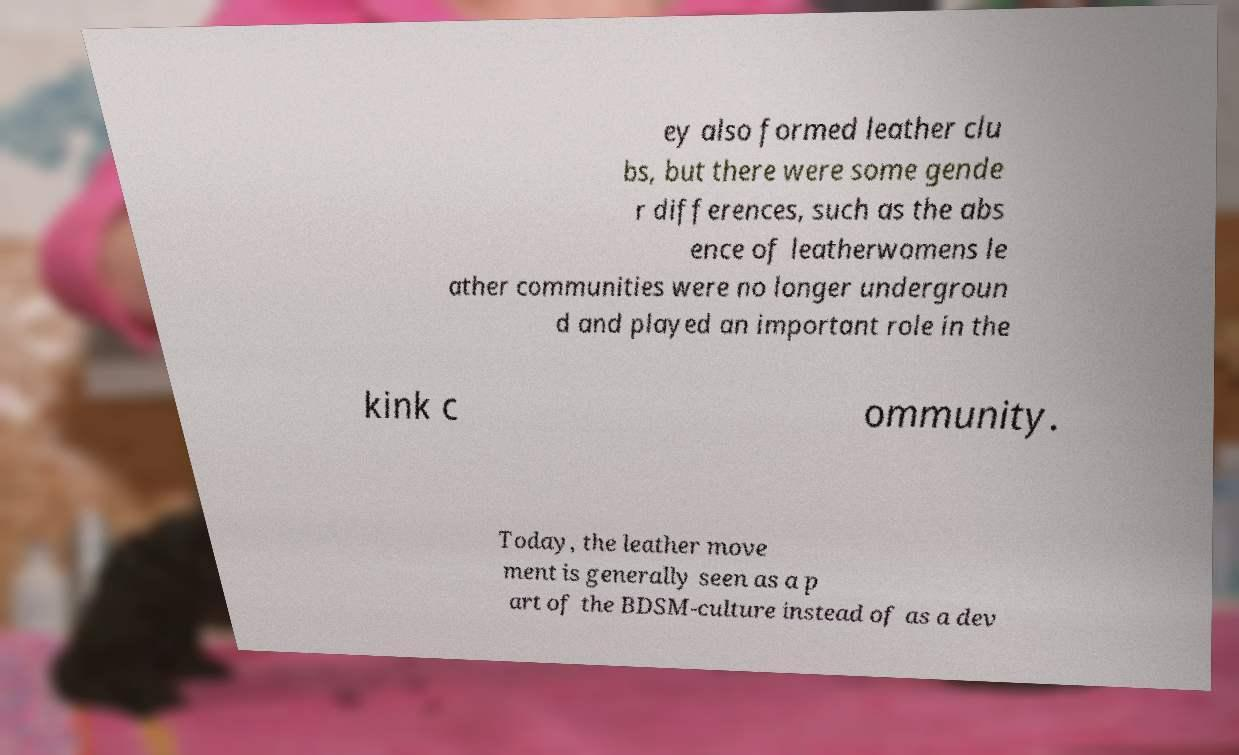For documentation purposes, I need the text within this image transcribed. Could you provide that? ey also formed leather clu bs, but there were some gende r differences, such as the abs ence of leatherwomens le ather communities were no longer undergroun d and played an important role in the kink c ommunity. Today, the leather move ment is generally seen as a p art of the BDSM-culture instead of as a dev 